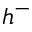<formula> <loc_0><loc_0><loc_500><loc_500>h ^ { - }</formula> 